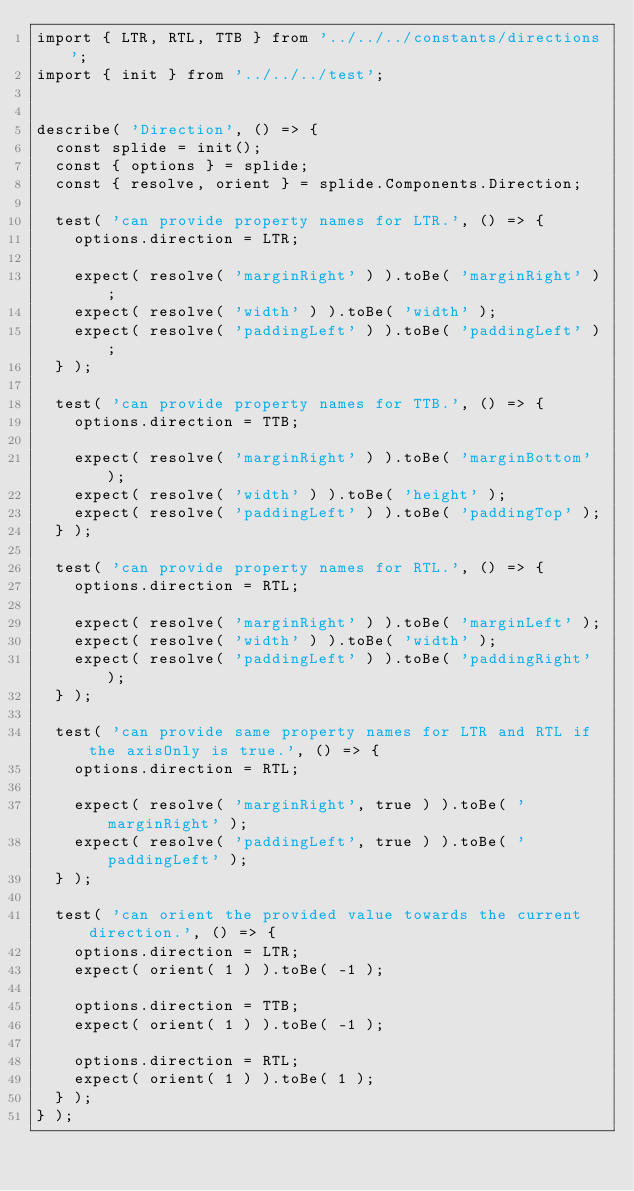<code> <loc_0><loc_0><loc_500><loc_500><_TypeScript_>import { LTR, RTL, TTB } from '../../../constants/directions';
import { init } from '../../../test';


describe( 'Direction', () => {
  const splide = init();
  const { options } = splide;
  const { resolve, orient } = splide.Components.Direction;

  test( 'can provide property names for LTR.', () => {
    options.direction = LTR;

    expect( resolve( 'marginRight' ) ).toBe( 'marginRight' );
    expect( resolve( 'width' ) ).toBe( 'width' );
    expect( resolve( 'paddingLeft' ) ).toBe( 'paddingLeft' );
  } );

  test( 'can provide property names for TTB.', () => {
    options.direction = TTB;

    expect( resolve( 'marginRight' ) ).toBe( 'marginBottom' );
    expect( resolve( 'width' ) ).toBe( 'height' );
    expect( resolve( 'paddingLeft' ) ).toBe( 'paddingTop' );
  } );

  test( 'can provide property names for RTL.', () => {
    options.direction = RTL;

    expect( resolve( 'marginRight' ) ).toBe( 'marginLeft' );
    expect( resolve( 'width' ) ).toBe( 'width' );
    expect( resolve( 'paddingLeft' ) ).toBe( 'paddingRight' );
  } );

  test( 'can provide same property names for LTR and RTL if the axisOnly is true.', () => {
    options.direction = RTL;

    expect( resolve( 'marginRight', true ) ).toBe( 'marginRight' );
    expect( resolve( 'paddingLeft', true ) ).toBe( 'paddingLeft' );
  } );

  test( 'can orient the provided value towards the current direction.', () => {
    options.direction = LTR;
    expect( orient( 1 ) ).toBe( -1 );

    options.direction = TTB;
    expect( orient( 1 ) ).toBe( -1 );

    options.direction = RTL;
    expect( orient( 1 ) ).toBe( 1 );
  } );
} );
</code> 